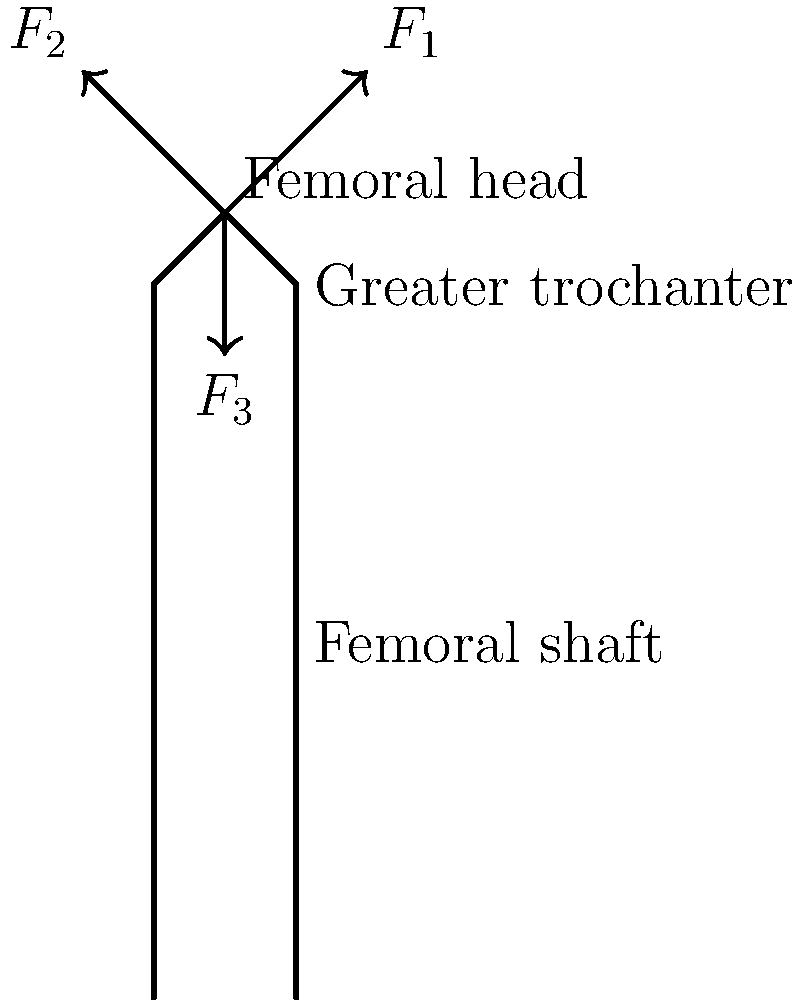In the diagram above, which force vector ($F_1$, $F_2$, or $F_3$) most likely represents the stress pattern caused by the abductor muscles during bipedal locomotion in early hominins? Explain how this stress pattern might have influenced the morphological adaptations observed in archaeological femur specimens. To answer this question, let's consider the biomechanics of bipedal locomotion and the stress patterns on the femur:

1. During bipedal walking, the abductor muscles play a crucial role in stabilizing the pelvis and maintaining balance.

2. The abductor muscles attach to the greater trochanter of the femur and pull laterally and slightly upward.

3. This action creates a force that counteracts the downward pull of body weight on the opposite side of the pelvis during the single-leg stance phase of walking.

4. In the diagram, $F_1$ represents a force vector pointing upward and laterally from the greater trochanter region, which most closely matches the direction of force exerted by the abductor muscles.

5. This stress pattern would have influenced morphological adaptations in the following ways:
   a. Enlargement of the greater trochanter to provide a larger attachment site for the abductor muscles.
   b. Increased cortical bone thickness in the femoral shaft to resist bending forces.
   c. Changes in the femoral neck angle to optimize force distribution.

6. Archaeological femur specimens from early hominins often show these adaptations, indicating a shift towards more efficient bipedal locomotion over time.

7. Sylvia Hallam's work on Australian Aboriginal archaeology, while not directly related to hominin evolution, emphasizes the importance of understanding how environmental factors influence human adaptations. This concept can be applied to interpreting the biomechanical adaptations seen in early hominin fossils.
Answer: $F_1$ (abductor muscle force) 